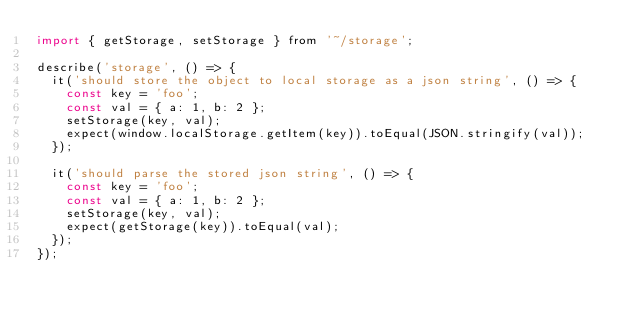Convert code to text. <code><loc_0><loc_0><loc_500><loc_500><_JavaScript_>import { getStorage, setStorage } from '~/storage';

describe('storage', () => {
  it('should store the object to local storage as a json string', () => {
    const key = 'foo';
    const val = { a: 1, b: 2 };
    setStorage(key, val);
    expect(window.localStorage.getItem(key)).toEqual(JSON.stringify(val));
  });

  it('should parse the stored json string', () => {
    const key = 'foo';
    const val = { a: 1, b: 2 };
    setStorage(key, val);
    expect(getStorage(key)).toEqual(val);
  });
});
</code> 